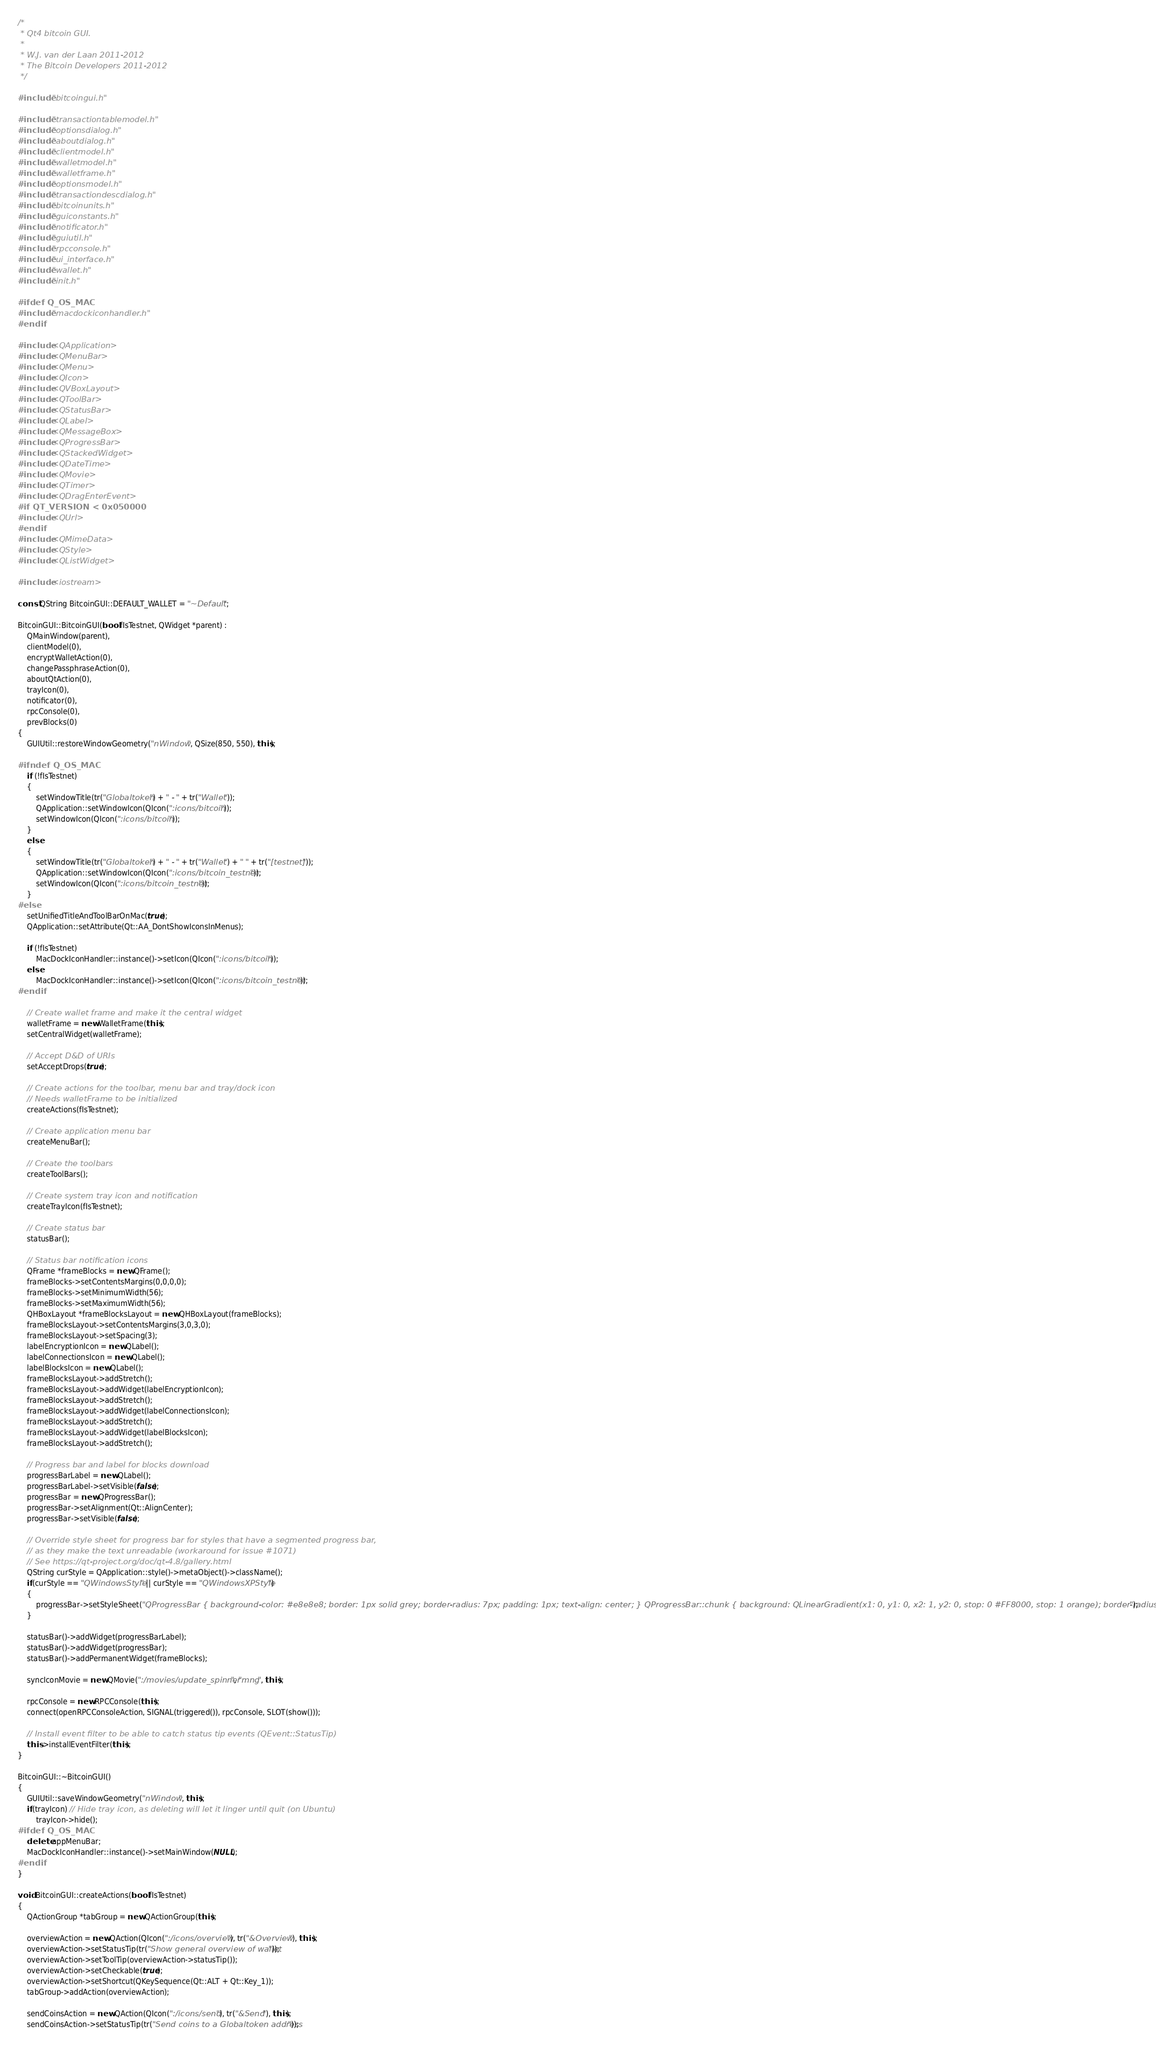Convert code to text. <code><loc_0><loc_0><loc_500><loc_500><_C++_>/*
 * Qt4 bitcoin GUI.
 *
 * W.J. van der Laan 2011-2012
 * The Bitcoin Developers 2011-2012
 */

#include "bitcoingui.h"

#include "transactiontablemodel.h"
#include "optionsdialog.h"
#include "aboutdialog.h"
#include "clientmodel.h"
#include "walletmodel.h"
#include "walletframe.h"
#include "optionsmodel.h"
#include "transactiondescdialog.h"
#include "bitcoinunits.h"
#include "guiconstants.h"
#include "notificator.h"
#include "guiutil.h"
#include "rpcconsole.h"
#include "ui_interface.h"
#include "wallet.h"
#include "init.h"

#ifdef Q_OS_MAC
#include "macdockiconhandler.h"
#endif

#include <QApplication>
#include <QMenuBar>
#include <QMenu>
#include <QIcon>
#include <QVBoxLayout>
#include <QToolBar>
#include <QStatusBar>
#include <QLabel>
#include <QMessageBox>
#include <QProgressBar>
#include <QStackedWidget>
#include <QDateTime>
#include <QMovie>
#include <QTimer>
#include <QDragEnterEvent>
#if QT_VERSION < 0x050000
#include <QUrl>
#endif
#include <QMimeData>
#include <QStyle>
#include <QListWidget>

#include <iostream>

const QString BitcoinGUI::DEFAULT_WALLET = "~Default";

BitcoinGUI::BitcoinGUI(bool fIsTestnet, QWidget *parent) :
    QMainWindow(parent),
    clientModel(0),
    encryptWalletAction(0),
    changePassphraseAction(0),
    aboutQtAction(0),
    trayIcon(0),
    notificator(0),
    rpcConsole(0),
    prevBlocks(0)
{
    GUIUtil::restoreWindowGeometry("nWindow", QSize(850, 550), this);

#ifndef Q_OS_MAC
    if (!fIsTestnet)
    {
        setWindowTitle(tr("Globaltoken") + " - " + tr("Wallet"));
        QApplication::setWindowIcon(QIcon(":icons/bitcoin"));
        setWindowIcon(QIcon(":icons/bitcoin"));
    }
    else
    {
        setWindowTitle(tr("Globaltoken") + " - " + tr("Wallet") + " " + tr("[testnet]"));
        QApplication::setWindowIcon(QIcon(":icons/bitcoin_testnet"));
        setWindowIcon(QIcon(":icons/bitcoin_testnet"));
    }
#else
    setUnifiedTitleAndToolBarOnMac(true);
    QApplication::setAttribute(Qt::AA_DontShowIconsInMenus);

    if (!fIsTestnet)
        MacDockIconHandler::instance()->setIcon(QIcon(":icons/bitcoin"));
    else
        MacDockIconHandler::instance()->setIcon(QIcon(":icons/bitcoin_testnet"));
#endif

    // Create wallet frame and make it the central widget
    walletFrame = new WalletFrame(this);
    setCentralWidget(walletFrame);

    // Accept D&D of URIs
    setAcceptDrops(true);

    // Create actions for the toolbar, menu bar and tray/dock icon
    // Needs walletFrame to be initialized
    createActions(fIsTestnet);

    // Create application menu bar
    createMenuBar();

    // Create the toolbars
    createToolBars();

    // Create system tray icon and notification
    createTrayIcon(fIsTestnet);

    // Create status bar
    statusBar();

    // Status bar notification icons
    QFrame *frameBlocks = new QFrame();
    frameBlocks->setContentsMargins(0,0,0,0);
    frameBlocks->setMinimumWidth(56);
    frameBlocks->setMaximumWidth(56);
    QHBoxLayout *frameBlocksLayout = new QHBoxLayout(frameBlocks);
    frameBlocksLayout->setContentsMargins(3,0,3,0);
    frameBlocksLayout->setSpacing(3);
    labelEncryptionIcon = new QLabel();
    labelConnectionsIcon = new QLabel();
    labelBlocksIcon = new QLabel();
    frameBlocksLayout->addStretch();
    frameBlocksLayout->addWidget(labelEncryptionIcon);
    frameBlocksLayout->addStretch();
    frameBlocksLayout->addWidget(labelConnectionsIcon);
    frameBlocksLayout->addStretch();
    frameBlocksLayout->addWidget(labelBlocksIcon);
    frameBlocksLayout->addStretch();

    // Progress bar and label for blocks download
    progressBarLabel = new QLabel();
    progressBarLabel->setVisible(false);
    progressBar = new QProgressBar();
    progressBar->setAlignment(Qt::AlignCenter);
    progressBar->setVisible(false);

    // Override style sheet for progress bar for styles that have a segmented progress bar,
    // as they make the text unreadable (workaround for issue #1071)
    // See https://qt-project.org/doc/qt-4.8/gallery.html
    QString curStyle = QApplication::style()->metaObject()->className();
    if(curStyle == "QWindowsStyle" || curStyle == "QWindowsXPStyle")
    {
        progressBar->setStyleSheet("QProgressBar { background-color: #e8e8e8; border: 1px solid grey; border-radius: 7px; padding: 1px; text-align: center; } QProgressBar::chunk { background: QLinearGradient(x1: 0, y1: 0, x2: 1, y2: 0, stop: 0 #FF8000, stop: 1 orange); border-radius: 7px; margin: 0px; }");
    }

    statusBar()->addWidget(progressBarLabel);
    statusBar()->addWidget(progressBar);
    statusBar()->addPermanentWidget(frameBlocks);

    syncIconMovie = new QMovie(":/movies/update_spinner", "mng", this);

    rpcConsole = new RPCConsole(this);
    connect(openRPCConsoleAction, SIGNAL(triggered()), rpcConsole, SLOT(show()));

    // Install event filter to be able to catch status tip events (QEvent::StatusTip)
    this->installEventFilter(this);
}

BitcoinGUI::~BitcoinGUI()
{
    GUIUtil::saveWindowGeometry("nWindow", this);
    if(trayIcon) // Hide tray icon, as deleting will let it linger until quit (on Ubuntu)
        trayIcon->hide();
#ifdef Q_OS_MAC
    delete appMenuBar;
    MacDockIconHandler::instance()->setMainWindow(NULL);
#endif
}

void BitcoinGUI::createActions(bool fIsTestnet)
{
    QActionGroup *tabGroup = new QActionGroup(this);

    overviewAction = new QAction(QIcon(":/icons/overview"), tr("&Overview"), this);
    overviewAction->setStatusTip(tr("Show general overview of wallet"));
    overviewAction->setToolTip(overviewAction->statusTip());
    overviewAction->setCheckable(true);
    overviewAction->setShortcut(QKeySequence(Qt::ALT + Qt::Key_1));
    tabGroup->addAction(overviewAction);

    sendCoinsAction = new QAction(QIcon(":/icons/send"), tr("&Send"), this);
    sendCoinsAction->setStatusTip(tr("Send coins to a Globaltoken address"));</code> 